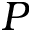Convert formula to latex. <formula><loc_0><loc_0><loc_500><loc_500>P</formula> 